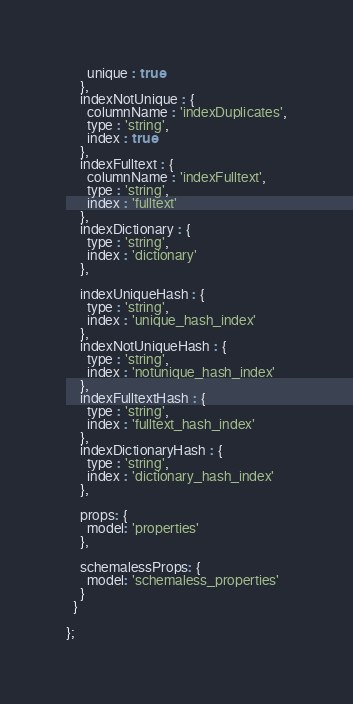Convert code to text. <code><loc_0><loc_0><loc_500><loc_500><_JavaScript_>      unique : true
    },
    indexNotUnique : {
      columnName : 'indexDuplicates',
      type : 'string',
      index : true
    },
    indexFulltext : {
      columnName : 'indexFulltext',
      type : 'string',
      index : 'fulltext'
    },
    indexDictionary : {
      type : 'string',
      index : 'dictionary'
    },
    
    indexUniqueHash : {
      type : 'string',
      index : 'unique_hash_index'
    },
    indexNotUniqueHash : {
      type : 'string',
      index : 'notunique_hash_index'
    },
    indexFulltextHash : {
      type : 'string',
      index : 'fulltext_hash_index'
    },
    indexDictionaryHash : {
      type : 'string',
      index : 'dictionary_hash_index'
    },
    
    props: {
      model: 'properties'
    },
    
    schemalessProps: {
      model: 'schemaless_properties'
    }
  }

};
</code> 